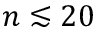Convert formula to latex. <formula><loc_0><loc_0><loc_500><loc_500>n \lesssim 2 0</formula> 